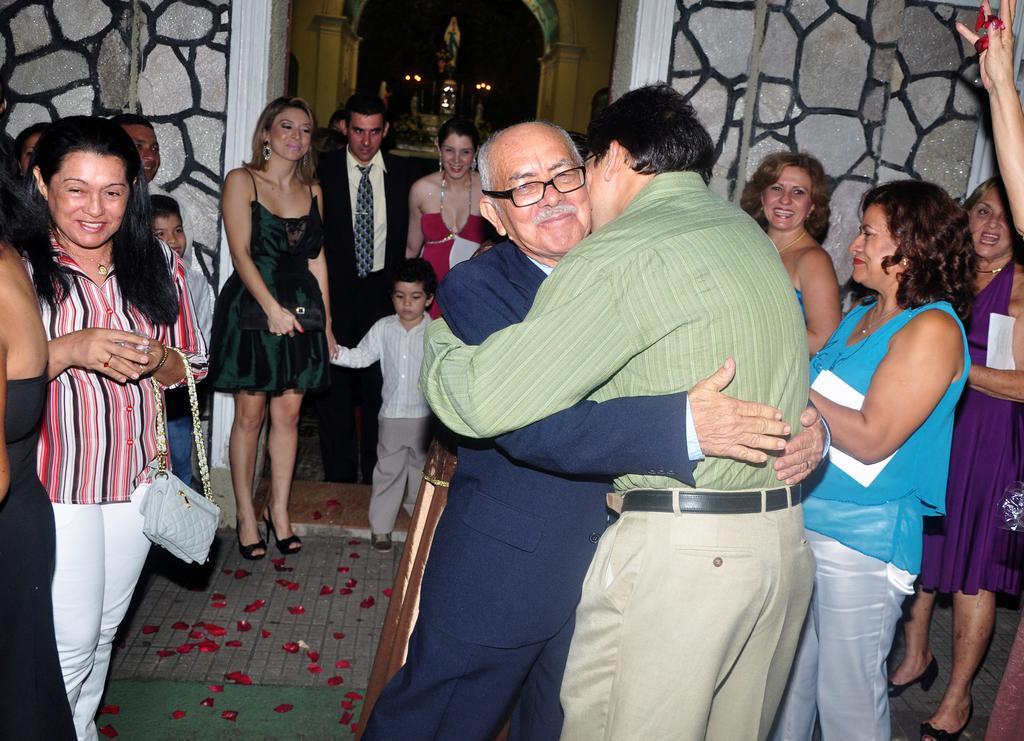How would you summarize this image in a sentence or two? In this image I can see group of people standing. There are walls, there is an arch and there are some other objects. 